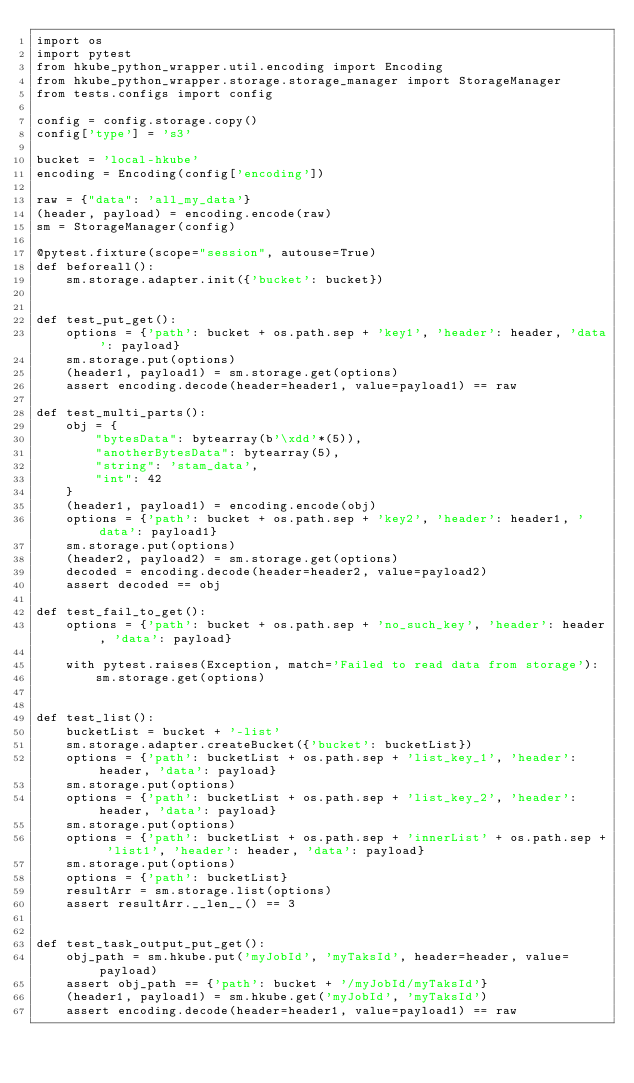<code> <loc_0><loc_0><loc_500><loc_500><_Python_>import os
import pytest
from hkube_python_wrapper.util.encoding import Encoding
from hkube_python_wrapper.storage.storage_manager import StorageManager
from tests.configs import config

config = config.storage.copy()
config['type'] = 's3'

bucket = 'local-hkube'
encoding = Encoding(config['encoding'])

raw = {"data": 'all_my_data'}
(header, payload) = encoding.encode(raw)
sm = StorageManager(config)

@pytest.fixture(scope="session", autouse=True)
def beforeall():
    sm.storage.adapter.init({'bucket': bucket})


def test_put_get():
    options = {'path': bucket + os.path.sep + 'key1', 'header': header, 'data': payload}
    sm.storage.put(options)
    (header1, payload1) = sm.storage.get(options)
    assert encoding.decode(header=header1, value=payload1) == raw

def test_multi_parts():
    obj = {
        "bytesData": bytearray(b'\xdd'*(5)),
        "anotherBytesData": bytearray(5),
        "string": 'stam_data',
        "int": 42
    }
    (header1, payload1) = encoding.encode(obj)
    options = {'path': bucket + os.path.sep + 'key2', 'header': header1, 'data': payload1}
    sm.storage.put(options)
    (header2, payload2) = sm.storage.get(options)
    decoded = encoding.decode(header=header2, value=payload2)
    assert decoded == obj

def test_fail_to_get():
    options = {'path': bucket + os.path.sep + 'no_such_key', 'header': header, 'data': payload}

    with pytest.raises(Exception, match='Failed to read data from storage'):
        sm.storage.get(options)


def test_list():
    bucketList = bucket + '-list'
    sm.storage.adapter.createBucket({'bucket': bucketList})
    options = {'path': bucketList + os.path.sep + 'list_key_1', 'header': header, 'data': payload}
    sm.storage.put(options)
    options = {'path': bucketList + os.path.sep + 'list_key_2', 'header': header, 'data': payload}
    sm.storage.put(options)
    options = {'path': bucketList + os.path.sep + 'innerList' + os.path.sep + 'list1', 'header': header, 'data': payload}
    sm.storage.put(options)
    options = {'path': bucketList}
    resultArr = sm.storage.list(options)
    assert resultArr.__len__() == 3


def test_task_output_put_get():
    obj_path = sm.hkube.put('myJobId', 'myTaksId', header=header, value=payload)
    assert obj_path == {'path': bucket + '/myJobId/myTaksId'}
    (header1, payload1) = sm.hkube.get('myJobId', 'myTaksId')
    assert encoding.decode(header=header1, value=payload1) == raw
</code> 